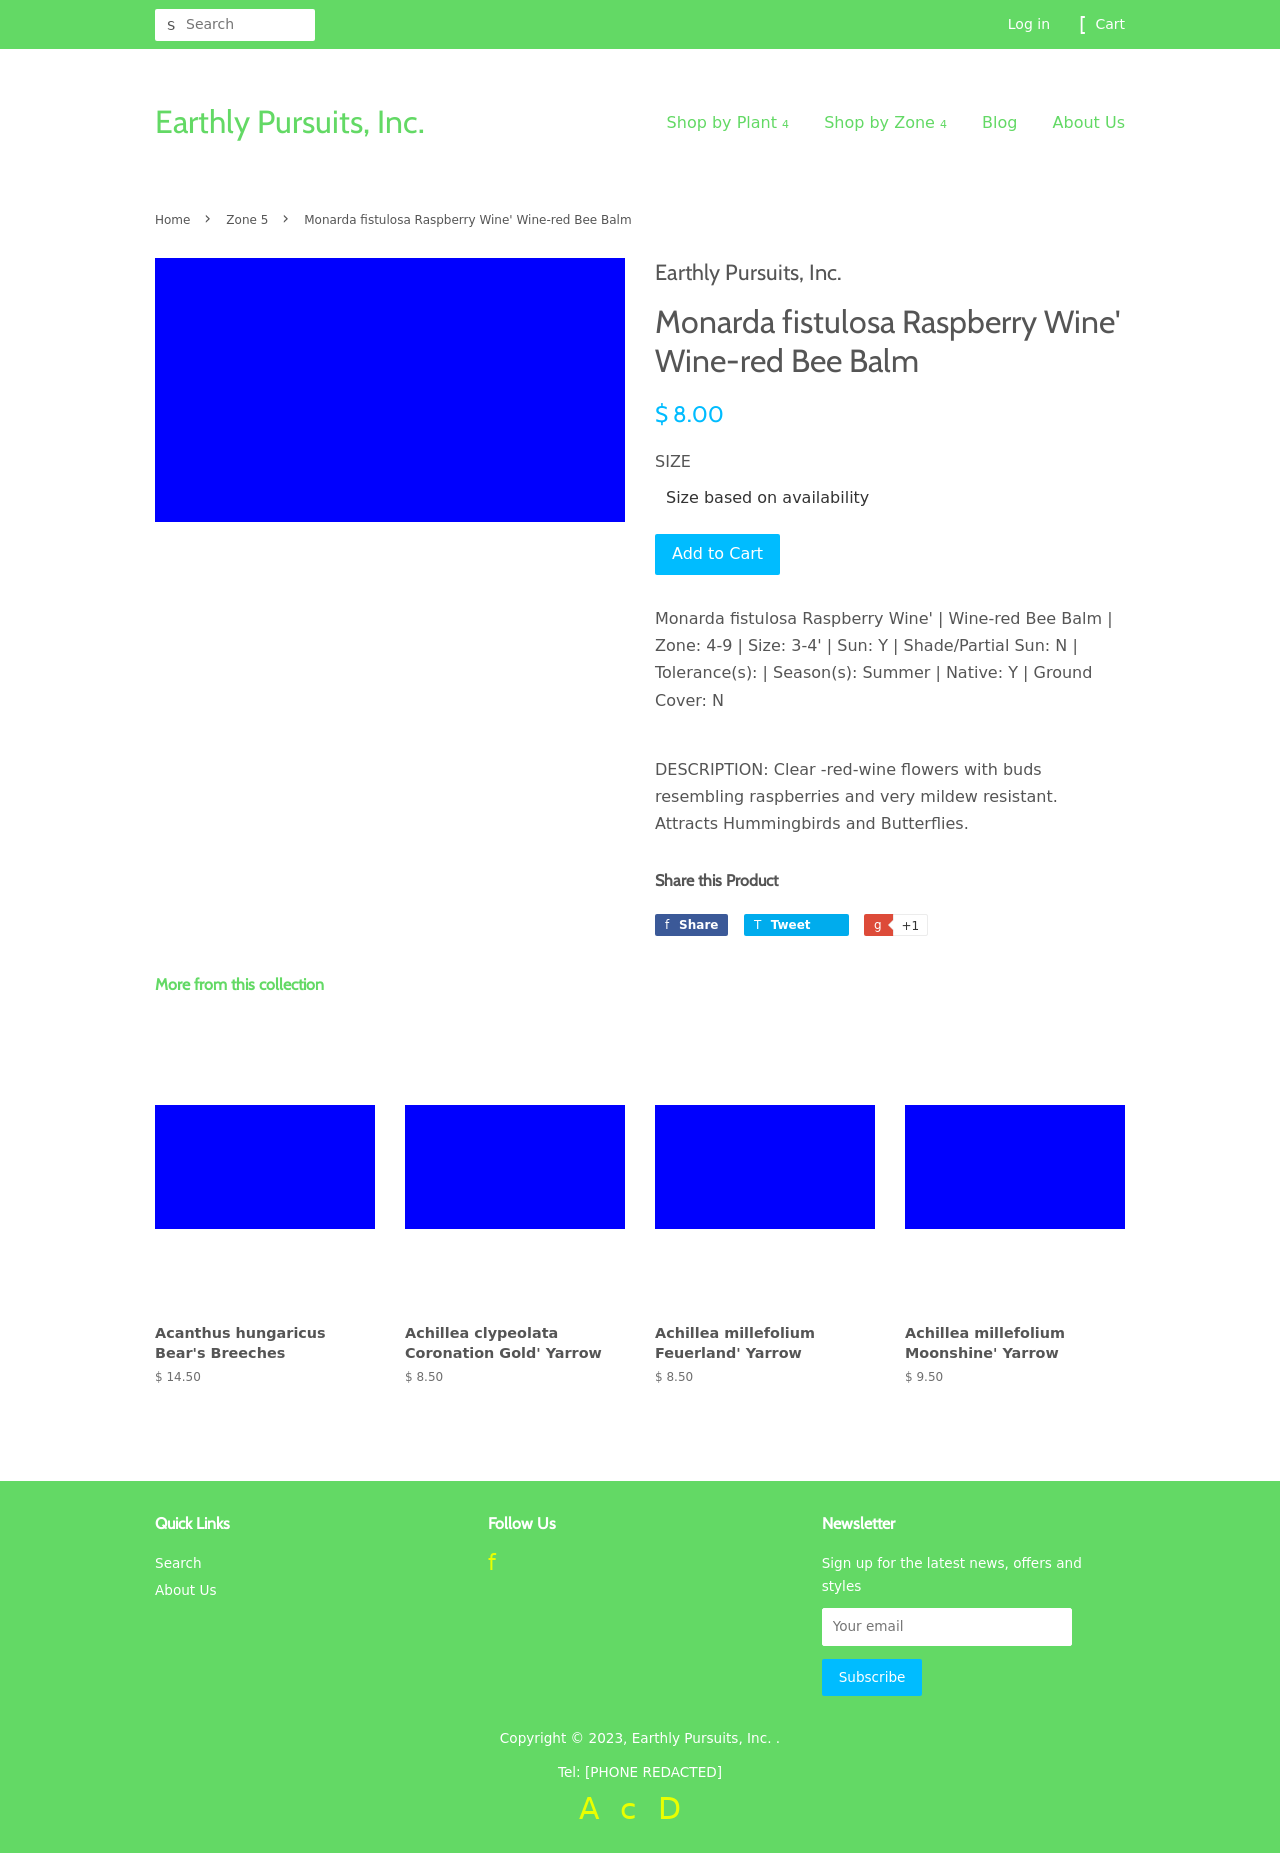What are the other plants listed under 'More from this collection' and their prices? The page lists several other plants under 'More from this collection', each presented with a simplified graphic placeholder in deep blue. These include 'Acanthus hungaricus Bear's Breeches' priced at $14.50, 'Achillea clypeolata Coronation Gold' Yarrow and 'Achillea millefolium Feuerland' Yarrow each priced at $8.50, and 'Achillea millefolium Moonshine' Yarrow at $9.50. All these images are placeholders, suggesting the actual images of plants are not displayed there. 
Can you provide details on the plant 'Acanthus hungaricus Bear's Breeches' shown in the collection? The 'Acanthus hungaricus Bear's Breeches' is an ornamental plant known for its robust size and unique foliage that makes it a popular choice for gardens. Typically, this plant features bold, spiny leaves and towering flower spikes that bloom white flowers framed by purple bracts, giving it a dramatic appearance. It prefers well-drained soil and partial to full sunlight, making it suitable for a variety of garden settings. Though the specific details like zone compatibility and size are not mentioned, it is generally known for its hardiness and architectural presence. 